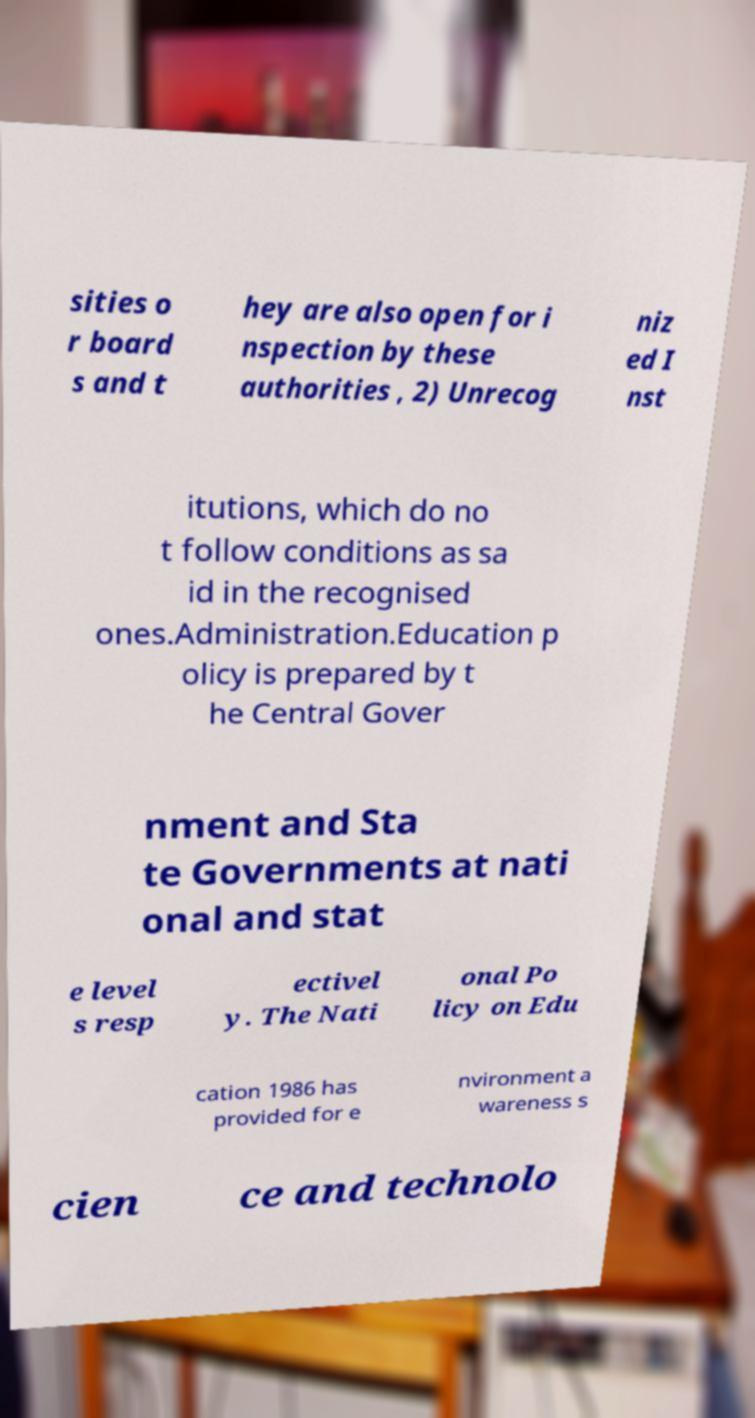Please identify and transcribe the text found in this image. sities o r board s and t hey are also open for i nspection by these authorities , 2) Unrecog niz ed I nst itutions, which do no t follow conditions as sa id in the recognised ones.Administration.Education p olicy is prepared by t he Central Gover nment and Sta te Governments at nati onal and stat e level s resp ectivel y. The Nati onal Po licy on Edu cation 1986 has provided for e nvironment a wareness s cien ce and technolo 